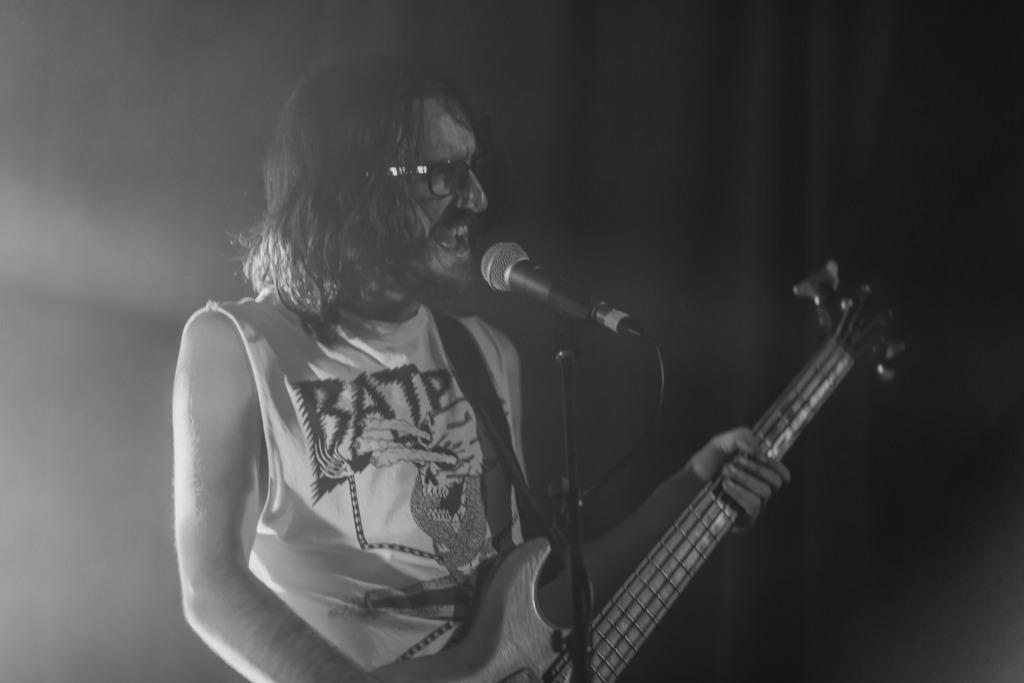How would you summarize this image in a sentence or two? In this picture we can see man wore spectacle holding guitar in his hand and playing it and singing on mic and in background it is dark. 